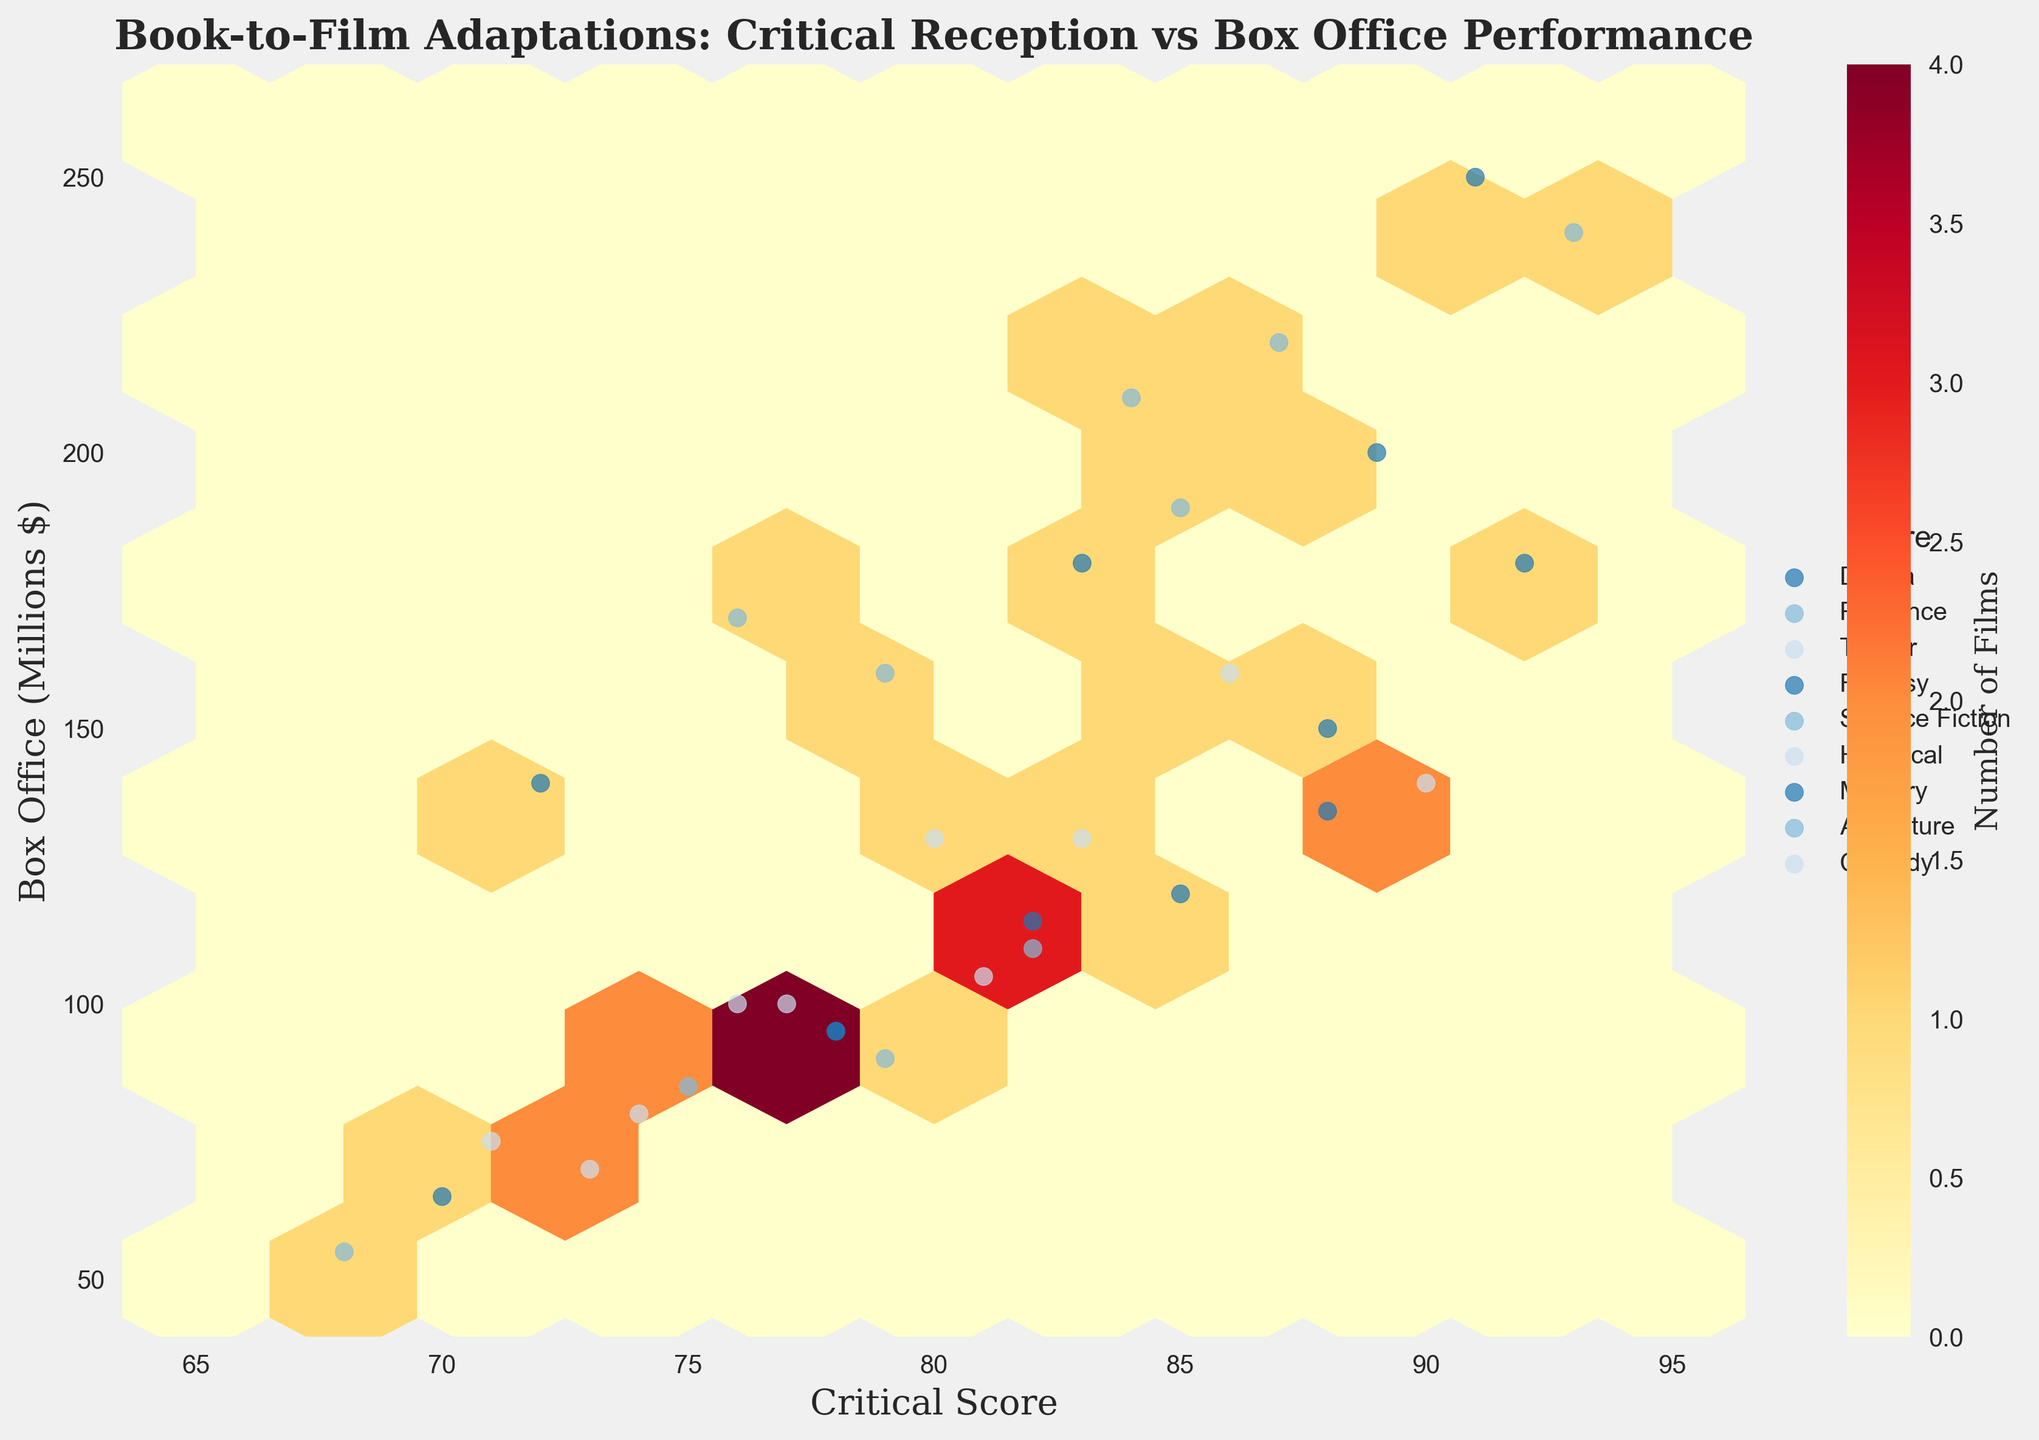What's the title of the figure? The title of the figure is displayed at the top of the plot. It reads "Book-to-Film Adaptations: Critical Reception vs Box Office Performance".
Answer: Book-to-Film Adaptations: Critical Reception vs Box Office Performance What are the labels of the x-axis and y-axis? The x-axis label is located below the horizontal axis and reads "Critical Score", while the y-axis label is located to the left of the vertical axis and reads "Box Office (Millions $)".
Answer: Critical Score and Box Office (Millions $) How many different genres are represented in the figure? The legend on the right side of the figure lists all the different genres. Close inspection shows there are 8 distinct genres: Drama, Romance, Thriller, Fantasy, Science Fiction, Historical, Mystery, and Adventure.
Answer: 8 Which genre appears to have the highest box office performance? By examining the scatter points for each genre, Fantasy has the highest box office performance with a maximum value around 250 million dollars.
Answer: Fantasy Which genres have the highest number of films clustered around? The color bar on the right indicates that darker hexagons represent a higher number of films. By looking at the hexbin density and the color intensity, Drama and Adventure have the highest number of films.
Answer: Drama and Adventure What is the relationship between Critical Score and Box Office Performance for Science Fiction films? By examining the plot, Science Fiction films tend to have high critical scores (above 75) and also perform well at the box office (above 170 million dollars).
Answer: High critical scores and well at the box office Is there a genre with a significant correlation between critical score and box office performance? A visual examination of the scatter points and their spread within and across hexagons indicates that Thriller shows some correlation, as higher critical scores tend to align with higher box office performances.
Answer: Thriller What is the color scheme used in the hexbin plot? The color scheme of the hexbin plot changes from light yellow to dark red, with darker red indicating a higher density of films.
Answer: Light yellow to dark red Which genre has the lowest critical score among its films? By examining the scattered points, Comedy contains a film with the lowest critical score of around 71.
Answer: Comedy 